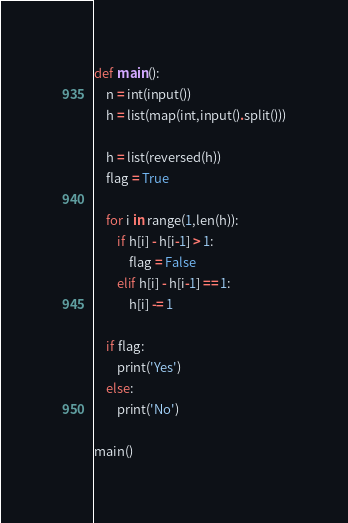<code> <loc_0><loc_0><loc_500><loc_500><_Python_>def main():
    n = int(input())
    h = list(map(int,input().split()))

    h = list(reversed(h))
    flag = True

    for i in range(1,len(h)):
        if h[i] - h[i-1] > 1:
            flag = False
        elif h[i] - h[i-1] == 1:
            h[i] -= 1
        
    if flag:
        print('Yes')
    else:
        print('No')

main()</code> 